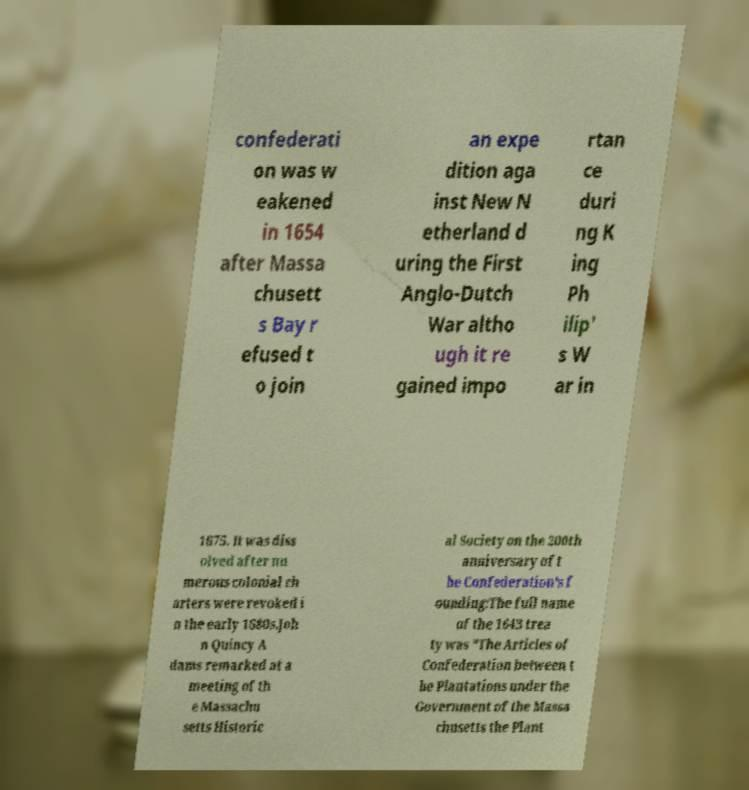Could you extract and type out the text from this image? confederati on was w eakened in 1654 after Massa chusett s Bay r efused t o join an expe dition aga inst New N etherland d uring the First Anglo-Dutch War altho ugh it re gained impo rtan ce duri ng K ing Ph ilip' s W ar in 1675. It was diss olved after nu merous colonial ch arters were revoked i n the early 1680s.Joh n Quincy A dams remarked at a meeting of th e Massachu setts Historic al Society on the 200th anniversary of t he Confederation's f ounding:The full name of the 1643 trea ty was "The Articles of Confederation between t he Plantations under the Government of the Massa chusetts the Plant 